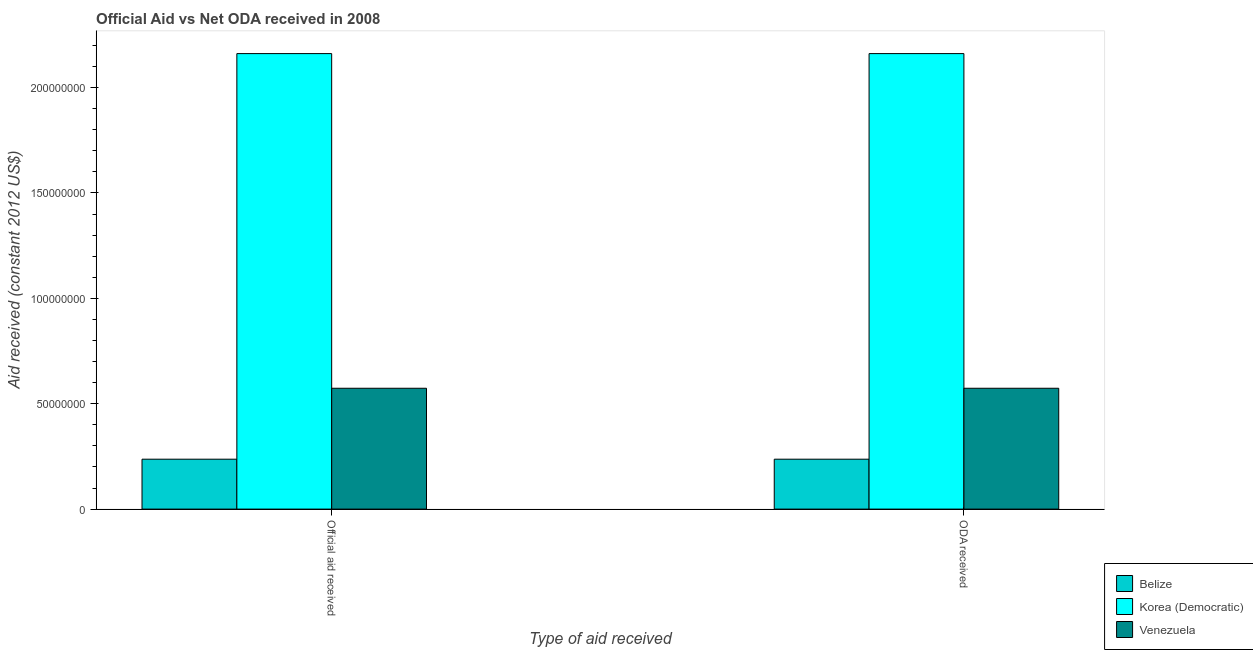How many different coloured bars are there?
Your response must be concise. 3. Are the number of bars per tick equal to the number of legend labels?
Offer a terse response. Yes. How many bars are there on the 1st tick from the right?
Offer a very short reply. 3. What is the label of the 2nd group of bars from the left?
Your answer should be compact. ODA received. What is the official aid received in Venezuela?
Your answer should be very brief. 5.73e+07. Across all countries, what is the maximum official aid received?
Offer a very short reply. 2.16e+08. Across all countries, what is the minimum official aid received?
Give a very brief answer. 2.37e+07. In which country was the oda received maximum?
Your response must be concise. Korea (Democratic). In which country was the official aid received minimum?
Keep it short and to the point. Belize. What is the total oda received in the graph?
Make the answer very short. 2.97e+08. What is the difference between the oda received in Belize and that in Venezuela?
Provide a short and direct response. -3.37e+07. What is the difference between the official aid received in Belize and the oda received in Venezuela?
Your answer should be compact. -3.37e+07. What is the average official aid received per country?
Keep it short and to the point. 9.90e+07. What is the difference between the official aid received and oda received in Korea (Democratic)?
Your answer should be compact. 0. What is the ratio of the official aid received in Korea (Democratic) to that in Venezuela?
Make the answer very short. 3.77. Is the official aid received in Belize less than that in Venezuela?
Keep it short and to the point. Yes. What does the 1st bar from the left in Official aid received represents?
Provide a succinct answer. Belize. What does the 1st bar from the right in Official aid received represents?
Offer a very short reply. Venezuela. How many bars are there?
Give a very brief answer. 6. Are all the bars in the graph horizontal?
Offer a terse response. No. How many countries are there in the graph?
Offer a terse response. 3. What is the difference between two consecutive major ticks on the Y-axis?
Your answer should be compact. 5.00e+07. Are the values on the major ticks of Y-axis written in scientific E-notation?
Offer a terse response. No. Where does the legend appear in the graph?
Provide a short and direct response. Bottom right. What is the title of the graph?
Offer a terse response. Official Aid vs Net ODA received in 2008 . What is the label or title of the X-axis?
Give a very brief answer. Type of aid received. What is the label or title of the Y-axis?
Your response must be concise. Aid received (constant 2012 US$). What is the Aid received (constant 2012 US$) of Belize in Official aid received?
Make the answer very short. 2.37e+07. What is the Aid received (constant 2012 US$) in Korea (Democratic) in Official aid received?
Give a very brief answer. 2.16e+08. What is the Aid received (constant 2012 US$) of Venezuela in Official aid received?
Offer a very short reply. 5.73e+07. What is the Aid received (constant 2012 US$) in Belize in ODA received?
Give a very brief answer. 2.37e+07. What is the Aid received (constant 2012 US$) of Korea (Democratic) in ODA received?
Ensure brevity in your answer.  2.16e+08. What is the Aid received (constant 2012 US$) of Venezuela in ODA received?
Your answer should be very brief. 5.73e+07. Across all Type of aid received, what is the maximum Aid received (constant 2012 US$) in Belize?
Your response must be concise. 2.37e+07. Across all Type of aid received, what is the maximum Aid received (constant 2012 US$) in Korea (Democratic)?
Provide a succinct answer. 2.16e+08. Across all Type of aid received, what is the maximum Aid received (constant 2012 US$) of Venezuela?
Your answer should be very brief. 5.73e+07. Across all Type of aid received, what is the minimum Aid received (constant 2012 US$) in Belize?
Your answer should be compact. 2.37e+07. Across all Type of aid received, what is the minimum Aid received (constant 2012 US$) in Korea (Democratic)?
Make the answer very short. 2.16e+08. Across all Type of aid received, what is the minimum Aid received (constant 2012 US$) in Venezuela?
Give a very brief answer. 5.73e+07. What is the total Aid received (constant 2012 US$) in Belize in the graph?
Ensure brevity in your answer.  4.74e+07. What is the total Aid received (constant 2012 US$) in Korea (Democratic) in the graph?
Offer a terse response. 4.32e+08. What is the total Aid received (constant 2012 US$) in Venezuela in the graph?
Offer a very short reply. 1.15e+08. What is the difference between the Aid received (constant 2012 US$) in Belize in Official aid received and that in ODA received?
Offer a terse response. 0. What is the difference between the Aid received (constant 2012 US$) of Korea (Democratic) in Official aid received and that in ODA received?
Offer a very short reply. 0. What is the difference between the Aid received (constant 2012 US$) of Venezuela in Official aid received and that in ODA received?
Your response must be concise. 0. What is the difference between the Aid received (constant 2012 US$) of Belize in Official aid received and the Aid received (constant 2012 US$) of Korea (Democratic) in ODA received?
Offer a terse response. -1.92e+08. What is the difference between the Aid received (constant 2012 US$) of Belize in Official aid received and the Aid received (constant 2012 US$) of Venezuela in ODA received?
Your answer should be very brief. -3.37e+07. What is the difference between the Aid received (constant 2012 US$) of Korea (Democratic) in Official aid received and the Aid received (constant 2012 US$) of Venezuela in ODA received?
Provide a short and direct response. 1.59e+08. What is the average Aid received (constant 2012 US$) in Belize per Type of aid received?
Offer a very short reply. 2.37e+07. What is the average Aid received (constant 2012 US$) in Korea (Democratic) per Type of aid received?
Offer a very short reply. 2.16e+08. What is the average Aid received (constant 2012 US$) of Venezuela per Type of aid received?
Offer a terse response. 5.73e+07. What is the difference between the Aid received (constant 2012 US$) of Belize and Aid received (constant 2012 US$) of Korea (Democratic) in Official aid received?
Provide a short and direct response. -1.92e+08. What is the difference between the Aid received (constant 2012 US$) of Belize and Aid received (constant 2012 US$) of Venezuela in Official aid received?
Your response must be concise. -3.37e+07. What is the difference between the Aid received (constant 2012 US$) of Korea (Democratic) and Aid received (constant 2012 US$) of Venezuela in Official aid received?
Keep it short and to the point. 1.59e+08. What is the difference between the Aid received (constant 2012 US$) in Belize and Aid received (constant 2012 US$) in Korea (Democratic) in ODA received?
Your answer should be very brief. -1.92e+08. What is the difference between the Aid received (constant 2012 US$) of Belize and Aid received (constant 2012 US$) of Venezuela in ODA received?
Your answer should be very brief. -3.37e+07. What is the difference between the Aid received (constant 2012 US$) in Korea (Democratic) and Aid received (constant 2012 US$) in Venezuela in ODA received?
Keep it short and to the point. 1.59e+08. What is the ratio of the Aid received (constant 2012 US$) of Belize in Official aid received to that in ODA received?
Offer a terse response. 1. What is the ratio of the Aid received (constant 2012 US$) in Korea (Democratic) in Official aid received to that in ODA received?
Your answer should be compact. 1. What is the ratio of the Aid received (constant 2012 US$) in Venezuela in Official aid received to that in ODA received?
Offer a very short reply. 1. 